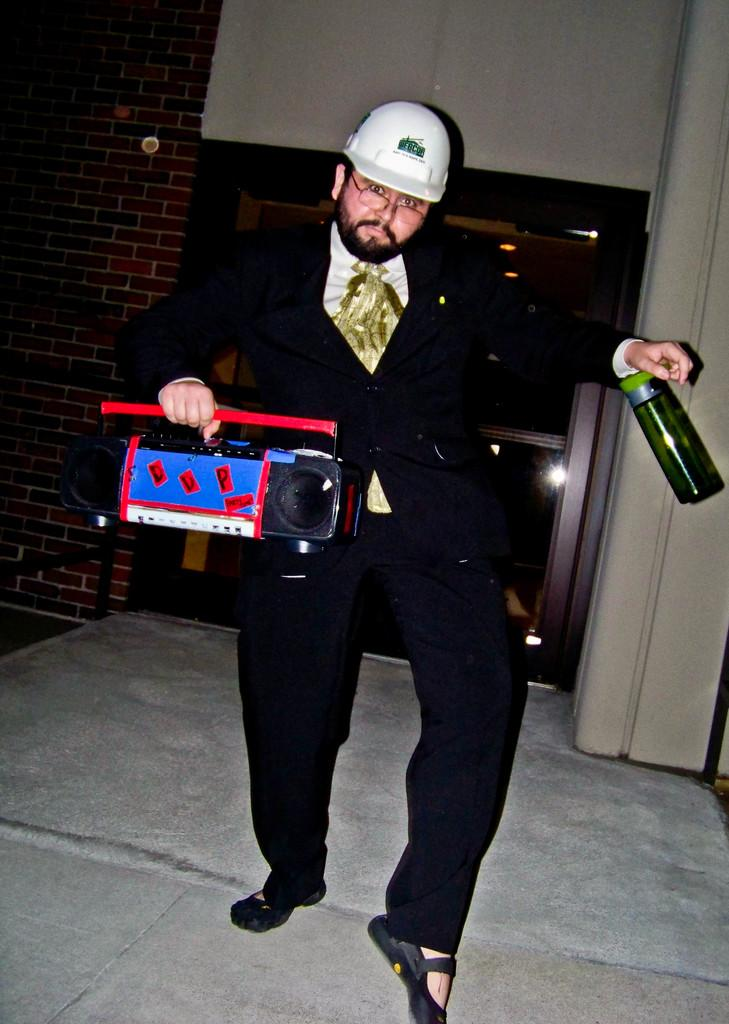What is the main subject of the image? There is a person in the image. What is the person holding in the image? The person is holding a tape recorder. Are there any other objects visible in the image? Yes, there is a bottle in the image. How many birds can be seen in the image? There are no birds visible in the image. What type of picture is the person holding in the image? The person is not holding a picture; they are holding a tape recorder. 